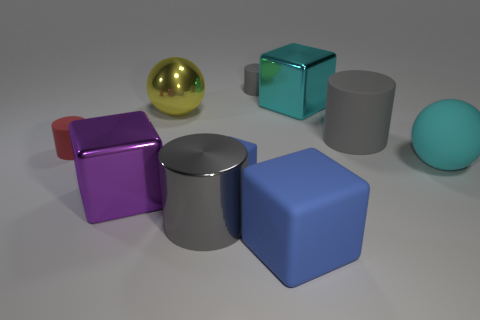What can you infer about the material of the objects? The objects seem to be made of various materials. The golden sphere and the teal cube appear reflective, suggesting they're made of a metal or glass. The matte gray cylinder and blue cube look like they could be made of a dull metal or plastic. The pronounced reflections and the way the light plays on their surfaces give us these clues. Which object seems out of place and why? The shiny golden sphere seems slightly out of place, not because of its shape, but due to its reflective, lustrous finish that contrasts with the other objects, which are either matte or only slightly reflective. 